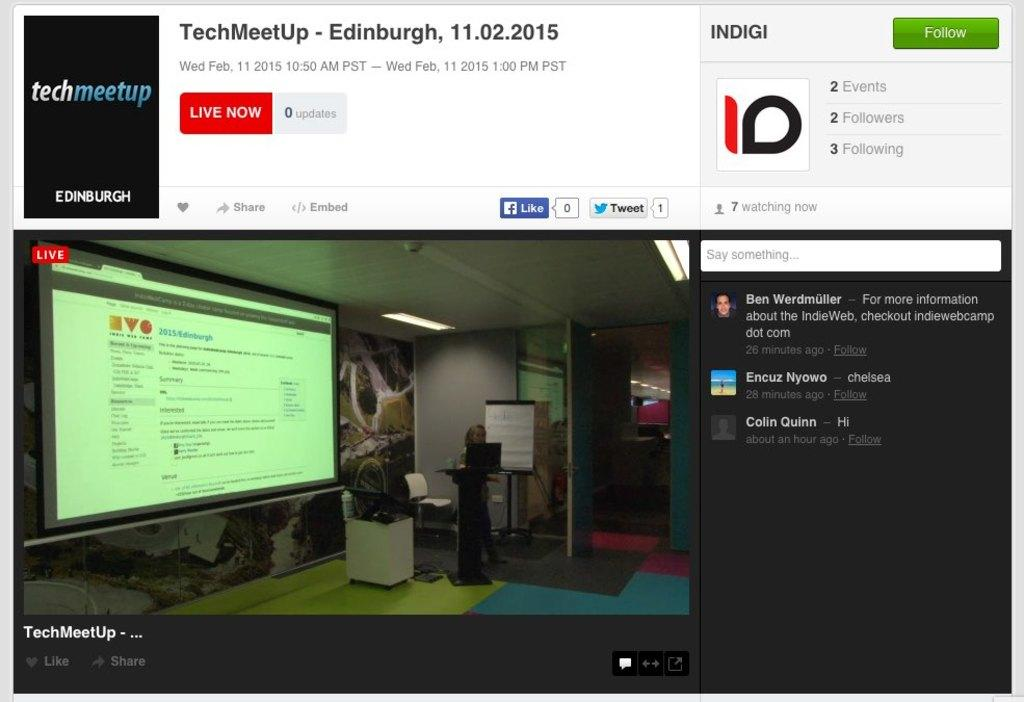<image>
Describe the image concisely. A techmeetup website that is showing a live presentation. 